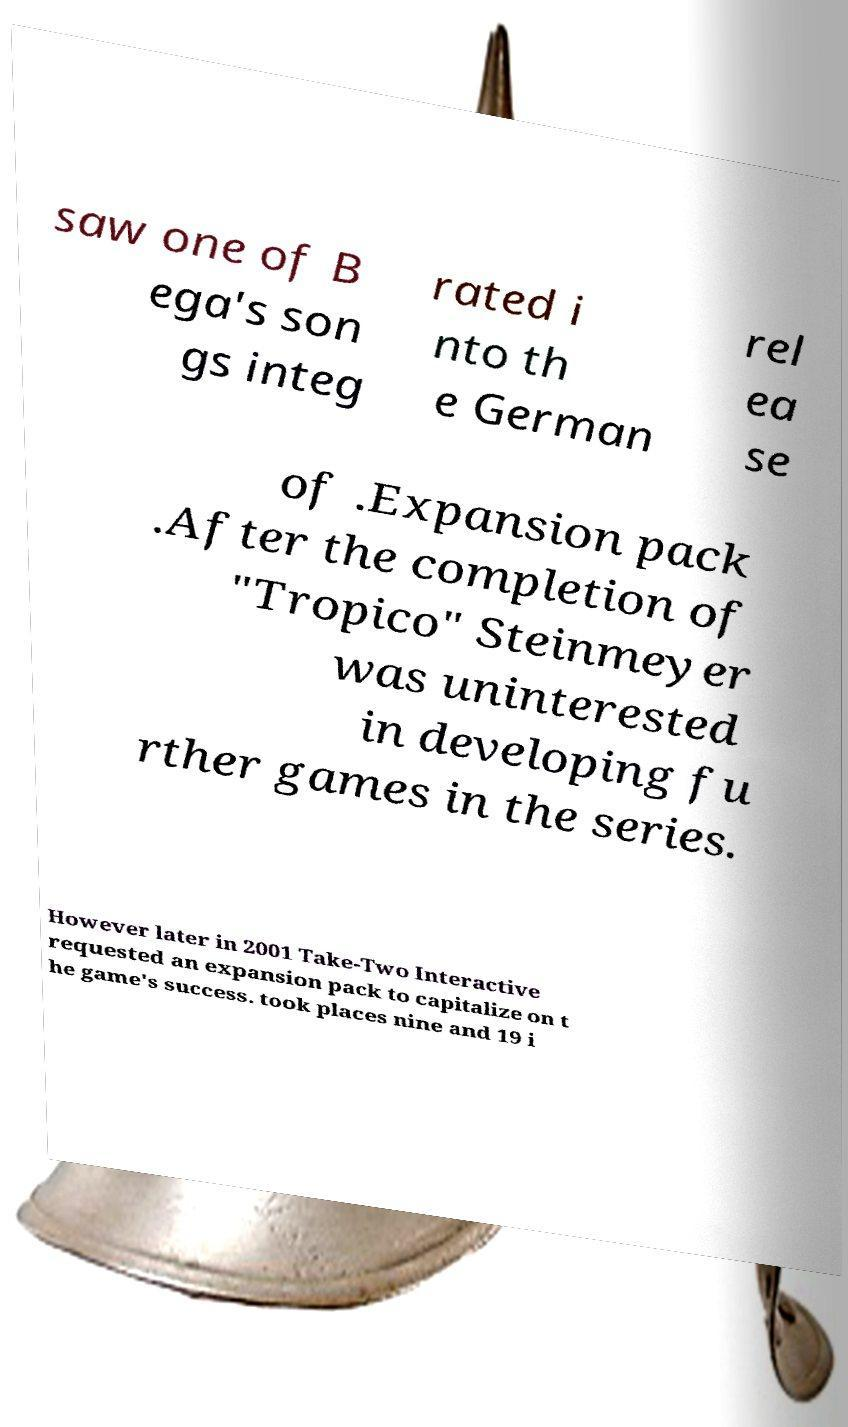Please identify and transcribe the text found in this image. saw one of B ega's son gs integ rated i nto th e German rel ea se of .Expansion pack .After the completion of "Tropico" Steinmeyer was uninterested in developing fu rther games in the series. However later in 2001 Take-Two Interactive requested an expansion pack to capitalize on t he game's success. took places nine and 19 i 